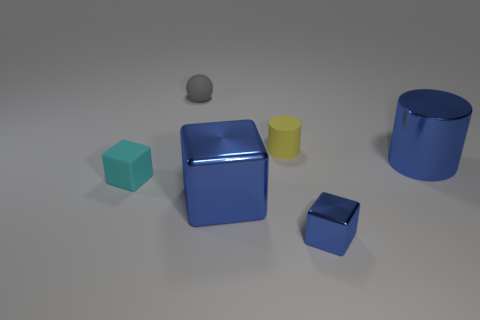Subtract all shiny blocks. How many blocks are left? 1 Subtract all cyan blocks. How many blocks are left? 2 Subtract all cyan balls. How many blue blocks are left? 2 Add 3 cyan metallic blocks. How many objects exist? 9 Subtract all balls. How many objects are left? 5 Subtract 1 blue cylinders. How many objects are left? 5 Subtract all purple cylinders. Subtract all gray cubes. How many cylinders are left? 2 Subtract all big blue cubes. Subtract all spheres. How many objects are left? 4 Add 6 blue metallic cubes. How many blue metallic cubes are left? 8 Add 5 rubber cylinders. How many rubber cylinders exist? 6 